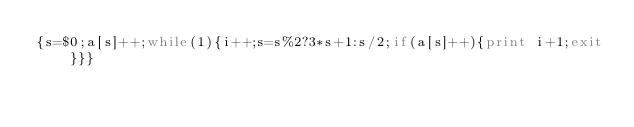Convert code to text. <code><loc_0><loc_0><loc_500><loc_500><_Awk_>{s=$0;a[s]++;while(1){i++;s=s%2?3*s+1:s/2;if(a[s]++){print i+1;exit}}}</code> 